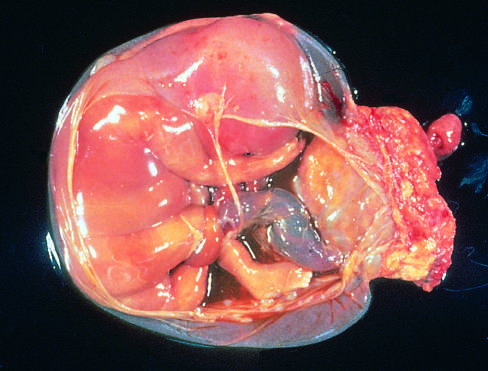s the placenta at the right, in the specimen shown?
Answer the question using a single word or phrase. Yes 